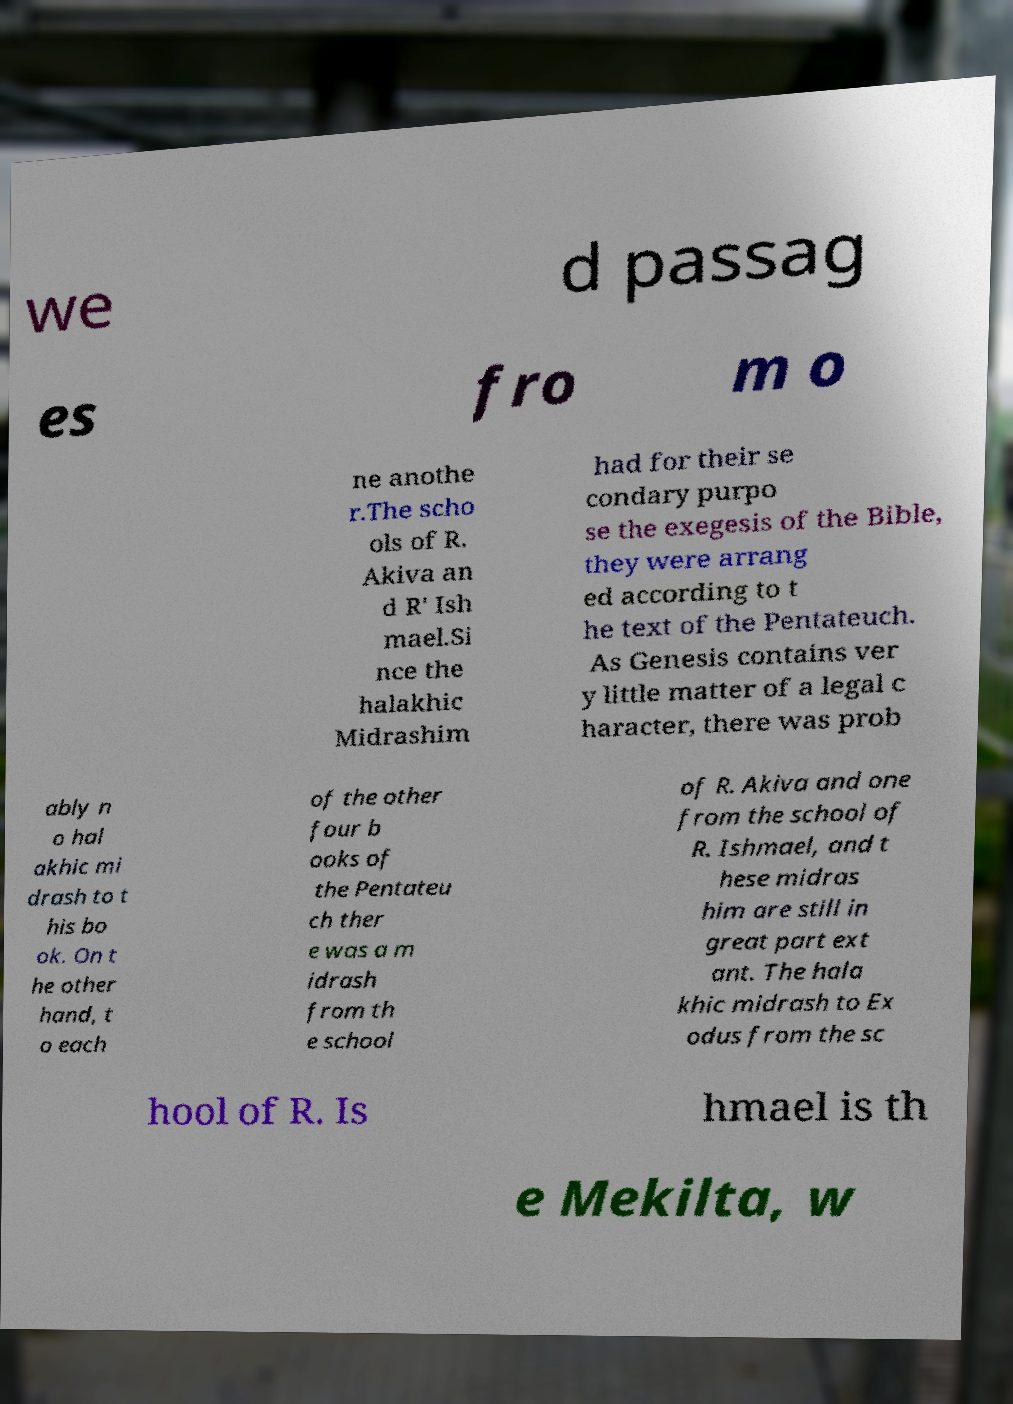I need the written content from this picture converted into text. Can you do that? we d passag es fro m o ne anothe r.The scho ols of R. Akiva an d R' Ish mael.Si nce the halakhic Midrashim had for their se condary purpo se the exegesis of the Bible, they were arrang ed according to t he text of the Pentateuch. As Genesis contains ver y little matter of a legal c haracter, there was prob ably n o hal akhic mi drash to t his bo ok. On t he other hand, t o each of the other four b ooks of the Pentateu ch ther e was a m idrash from th e school of R. Akiva and one from the school of R. Ishmael, and t hese midras him are still in great part ext ant. The hala khic midrash to Ex odus from the sc hool of R. Is hmael is th e Mekilta, w 